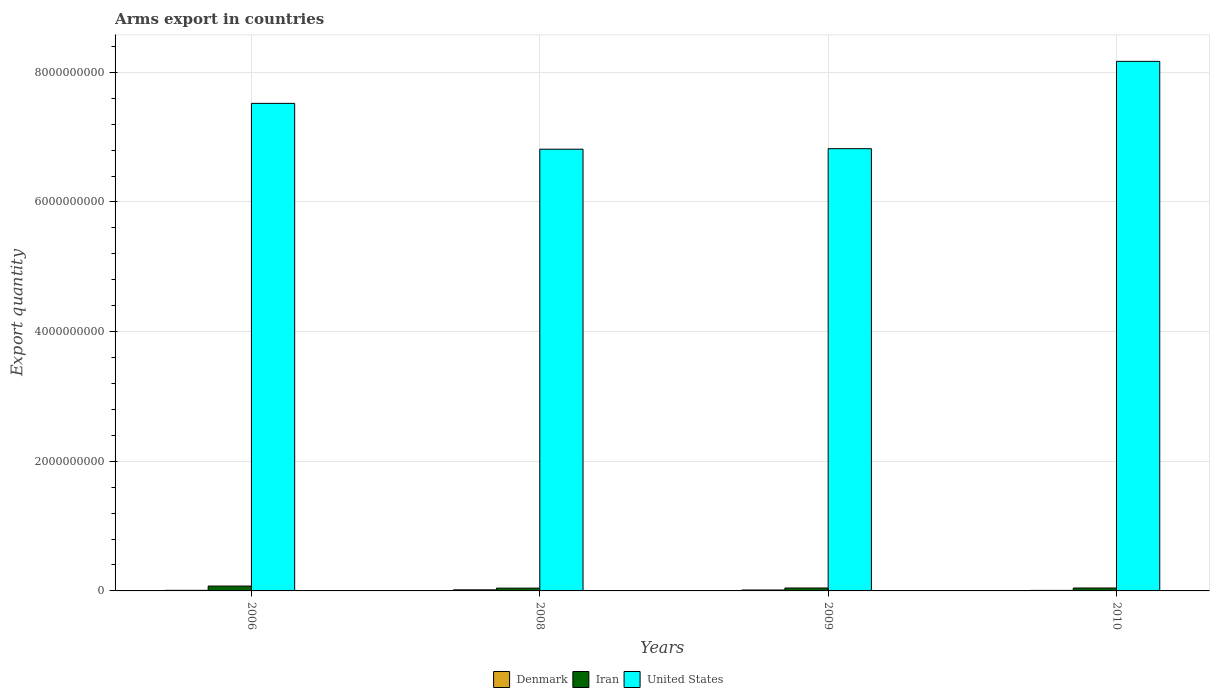How many different coloured bars are there?
Keep it short and to the point. 3. Are the number of bars per tick equal to the number of legend labels?
Give a very brief answer. Yes. Are the number of bars on each tick of the X-axis equal?
Make the answer very short. Yes. How many bars are there on the 1st tick from the left?
Offer a very short reply. 3. How many bars are there on the 1st tick from the right?
Provide a succinct answer. 3. What is the label of the 3rd group of bars from the left?
Provide a succinct answer. 2009. What is the total arms export in Denmark in 2008?
Give a very brief answer. 1.70e+07. Across all years, what is the maximum total arms export in United States?
Your answer should be very brief. 8.17e+09. Across all years, what is the minimum total arms export in Denmark?
Give a very brief answer. 8.00e+06. In which year was the total arms export in Iran minimum?
Offer a terse response. 2008. What is the total total arms export in Iran in the graph?
Ensure brevity in your answer.  2.08e+08. What is the difference between the total arms export in Iran in 2006 and that in 2008?
Keep it short and to the point. 3.20e+07. What is the difference between the total arms export in Iran in 2010 and the total arms export in United States in 2006?
Offer a terse response. -7.48e+09. What is the average total arms export in United States per year?
Your response must be concise. 7.33e+09. In the year 2009, what is the difference between the total arms export in Denmark and total arms export in United States?
Offer a very short reply. -6.81e+09. In how many years, is the total arms export in Iran greater than 6000000000?
Offer a very short reply. 0. What is the difference between the highest and the second highest total arms export in Iran?
Keep it short and to the point. 3.00e+07. What is the difference between the highest and the lowest total arms export in Iran?
Keep it short and to the point. 3.20e+07. In how many years, is the total arms export in United States greater than the average total arms export in United States taken over all years?
Ensure brevity in your answer.  2. What does the 1st bar from the right in 2009 represents?
Provide a succinct answer. United States. How many bars are there?
Your answer should be compact. 12. How many years are there in the graph?
Your answer should be compact. 4. Does the graph contain any zero values?
Keep it short and to the point. No. What is the title of the graph?
Make the answer very short. Arms export in countries. Does "Zimbabwe" appear as one of the legend labels in the graph?
Offer a terse response. No. What is the label or title of the X-axis?
Provide a short and direct response. Years. What is the label or title of the Y-axis?
Make the answer very short. Export quantity. What is the Export quantity of Denmark in 2006?
Ensure brevity in your answer.  9.00e+06. What is the Export quantity in Iran in 2006?
Your answer should be very brief. 7.50e+07. What is the Export quantity in United States in 2006?
Ensure brevity in your answer.  7.52e+09. What is the Export quantity in Denmark in 2008?
Your answer should be very brief. 1.70e+07. What is the Export quantity in Iran in 2008?
Make the answer very short. 4.30e+07. What is the Export quantity in United States in 2008?
Offer a very short reply. 6.81e+09. What is the Export quantity in Denmark in 2009?
Your response must be concise. 1.40e+07. What is the Export quantity of Iran in 2009?
Provide a short and direct response. 4.50e+07. What is the Export quantity in United States in 2009?
Your answer should be very brief. 6.82e+09. What is the Export quantity of Iran in 2010?
Your answer should be very brief. 4.50e+07. What is the Export quantity of United States in 2010?
Your answer should be compact. 8.17e+09. Across all years, what is the maximum Export quantity in Denmark?
Offer a terse response. 1.70e+07. Across all years, what is the maximum Export quantity of Iran?
Make the answer very short. 7.50e+07. Across all years, what is the maximum Export quantity of United States?
Provide a succinct answer. 8.17e+09. Across all years, what is the minimum Export quantity in Denmark?
Give a very brief answer. 8.00e+06. Across all years, what is the minimum Export quantity in Iran?
Provide a short and direct response. 4.30e+07. Across all years, what is the minimum Export quantity in United States?
Offer a very short reply. 6.81e+09. What is the total Export quantity of Denmark in the graph?
Your answer should be very brief. 4.80e+07. What is the total Export quantity of Iran in the graph?
Keep it short and to the point. 2.08e+08. What is the total Export quantity of United States in the graph?
Your answer should be very brief. 2.93e+1. What is the difference between the Export quantity of Denmark in 2006 and that in 2008?
Make the answer very short. -8.00e+06. What is the difference between the Export quantity in Iran in 2006 and that in 2008?
Your answer should be very brief. 3.20e+07. What is the difference between the Export quantity of United States in 2006 and that in 2008?
Your response must be concise. 7.07e+08. What is the difference between the Export quantity in Denmark in 2006 and that in 2009?
Ensure brevity in your answer.  -5.00e+06. What is the difference between the Export quantity of Iran in 2006 and that in 2009?
Provide a short and direct response. 3.00e+07. What is the difference between the Export quantity in United States in 2006 and that in 2009?
Provide a short and direct response. 6.99e+08. What is the difference between the Export quantity of Denmark in 2006 and that in 2010?
Make the answer very short. 1.00e+06. What is the difference between the Export quantity in Iran in 2006 and that in 2010?
Make the answer very short. 3.00e+07. What is the difference between the Export quantity of United States in 2006 and that in 2010?
Provide a succinct answer. -6.48e+08. What is the difference between the Export quantity of United States in 2008 and that in 2009?
Your answer should be compact. -8.00e+06. What is the difference between the Export quantity in Denmark in 2008 and that in 2010?
Your answer should be compact. 9.00e+06. What is the difference between the Export quantity of United States in 2008 and that in 2010?
Your answer should be compact. -1.36e+09. What is the difference between the Export quantity in United States in 2009 and that in 2010?
Your response must be concise. -1.35e+09. What is the difference between the Export quantity in Denmark in 2006 and the Export quantity in Iran in 2008?
Your response must be concise. -3.40e+07. What is the difference between the Export quantity in Denmark in 2006 and the Export quantity in United States in 2008?
Ensure brevity in your answer.  -6.80e+09. What is the difference between the Export quantity in Iran in 2006 and the Export quantity in United States in 2008?
Your answer should be very brief. -6.74e+09. What is the difference between the Export quantity in Denmark in 2006 and the Export quantity in Iran in 2009?
Provide a short and direct response. -3.60e+07. What is the difference between the Export quantity of Denmark in 2006 and the Export quantity of United States in 2009?
Provide a succinct answer. -6.81e+09. What is the difference between the Export quantity of Iran in 2006 and the Export quantity of United States in 2009?
Ensure brevity in your answer.  -6.75e+09. What is the difference between the Export quantity in Denmark in 2006 and the Export quantity in Iran in 2010?
Keep it short and to the point. -3.60e+07. What is the difference between the Export quantity in Denmark in 2006 and the Export quantity in United States in 2010?
Keep it short and to the point. -8.16e+09. What is the difference between the Export quantity in Iran in 2006 and the Export quantity in United States in 2010?
Make the answer very short. -8.09e+09. What is the difference between the Export quantity in Denmark in 2008 and the Export quantity in Iran in 2009?
Ensure brevity in your answer.  -2.80e+07. What is the difference between the Export quantity of Denmark in 2008 and the Export quantity of United States in 2009?
Your answer should be very brief. -6.80e+09. What is the difference between the Export quantity in Iran in 2008 and the Export quantity in United States in 2009?
Your answer should be compact. -6.78e+09. What is the difference between the Export quantity of Denmark in 2008 and the Export quantity of Iran in 2010?
Provide a succinct answer. -2.80e+07. What is the difference between the Export quantity in Denmark in 2008 and the Export quantity in United States in 2010?
Ensure brevity in your answer.  -8.15e+09. What is the difference between the Export quantity in Iran in 2008 and the Export quantity in United States in 2010?
Keep it short and to the point. -8.13e+09. What is the difference between the Export quantity in Denmark in 2009 and the Export quantity in Iran in 2010?
Ensure brevity in your answer.  -3.10e+07. What is the difference between the Export quantity of Denmark in 2009 and the Export quantity of United States in 2010?
Keep it short and to the point. -8.16e+09. What is the difference between the Export quantity of Iran in 2009 and the Export quantity of United States in 2010?
Ensure brevity in your answer.  -8.12e+09. What is the average Export quantity in Iran per year?
Provide a succinct answer. 5.20e+07. What is the average Export quantity of United States per year?
Offer a very short reply. 7.33e+09. In the year 2006, what is the difference between the Export quantity in Denmark and Export quantity in Iran?
Offer a very short reply. -6.60e+07. In the year 2006, what is the difference between the Export quantity of Denmark and Export quantity of United States?
Offer a very short reply. -7.51e+09. In the year 2006, what is the difference between the Export quantity in Iran and Export quantity in United States?
Make the answer very short. -7.45e+09. In the year 2008, what is the difference between the Export quantity of Denmark and Export quantity of Iran?
Provide a succinct answer. -2.60e+07. In the year 2008, what is the difference between the Export quantity in Denmark and Export quantity in United States?
Offer a terse response. -6.80e+09. In the year 2008, what is the difference between the Export quantity in Iran and Export quantity in United States?
Offer a terse response. -6.77e+09. In the year 2009, what is the difference between the Export quantity of Denmark and Export quantity of Iran?
Your answer should be very brief. -3.10e+07. In the year 2009, what is the difference between the Export quantity of Denmark and Export quantity of United States?
Your answer should be very brief. -6.81e+09. In the year 2009, what is the difference between the Export quantity of Iran and Export quantity of United States?
Provide a succinct answer. -6.78e+09. In the year 2010, what is the difference between the Export quantity in Denmark and Export quantity in Iran?
Give a very brief answer. -3.70e+07. In the year 2010, what is the difference between the Export quantity of Denmark and Export quantity of United States?
Ensure brevity in your answer.  -8.16e+09. In the year 2010, what is the difference between the Export quantity of Iran and Export quantity of United States?
Give a very brief answer. -8.12e+09. What is the ratio of the Export quantity in Denmark in 2006 to that in 2008?
Your answer should be compact. 0.53. What is the ratio of the Export quantity of Iran in 2006 to that in 2008?
Make the answer very short. 1.74. What is the ratio of the Export quantity in United States in 2006 to that in 2008?
Make the answer very short. 1.1. What is the ratio of the Export quantity in Denmark in 2006 to that in 2009?
Your response must be concise. 0.64. What is the ratio of the Export quantity in Iran in 2006 to that in 2009?
Your answer should be very brief. 1.67. What is the ratio of the Export quantity of United States in 2006 to that in 2009?
Ensure brevity in your answer.  1.1. What is the ratio of the Export quantity of United States in 2006 to that in 2010?
Your answer should be very brief. 0.92. What is the ratio of the Export quantity in Denmark in 2008 to that in 2009?
Your response must be concise. 1.21. What is the ratio of the Export quantity in Iran in 2008 to that in 2009?
Ensure brevity in your answer.  0.96. What is the ratio of the Export quantity of United States in 2008 to that in 2009?
Your answer should be compact. 1. What is the ratio of the Export quantity in Denmark in 2008 to that in 2010?
Make the answer very short. 2.12. What is the ratio of the Export quantity in Iran in 2008 to that in 2010?
Offer a very short reply. 0.96. What is the ratio of the Export quantity of United States in 2008 to that in 2010?
Your answer should be compact. 0.83. What is the ratio of the Export quantity of Denmark in 2009 to that in 2010?
Your answer should be compact. 1.75. What is the ratio of the Export quantity of United States in 2009 to that in 2010?
Offer a very short reply. 0.84. What is the difference between the highest and the second highest Export quantity in Iran?
Provide a short and direct response. 3.00e+07. What is the difference between the highest and the second highest Export quantity of United States?
Provide a succinct answer. 6.48e+08. What is the difference between the highest and the lowest Export quantity of Denmark?
Provide a succinct answer. 9.00e+06. What is the difference between the highest and the lowest Export quantity in Iran?
Offer a very short reply. 3.20e+07. What is the difference between the highest and the lowest Export quantity in United States?
Keep it short and to the point. 1.36e+09. 